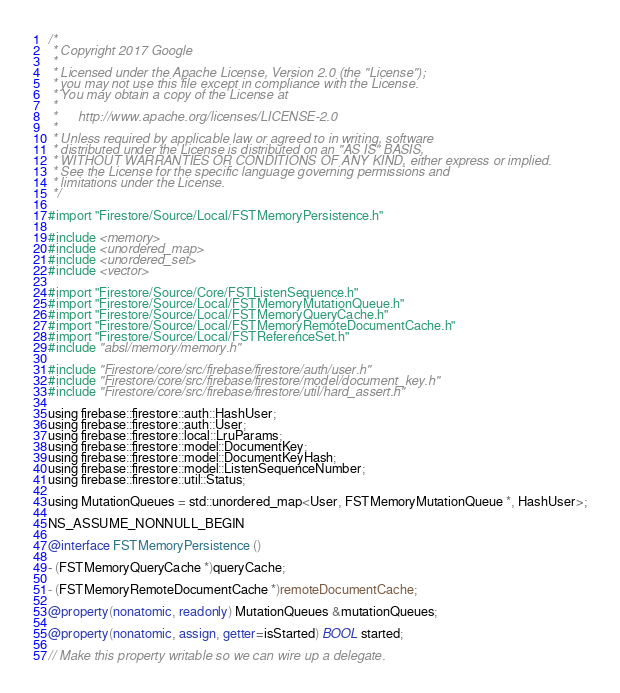Convert code to text. <code><loc_0><loc_0><loc_500><loc_500><_ObjectiveC_>/*
 * Copyright 2017 Google
 *
 * Licensed under the Apache License, Version 2.0 (the "License");
 * you may not use this file except in compliance with the License.
 * You may obtain a copy of the License at
 *
 *      http://www.apache.org/licenses/LICENSE-2.0
 *
 * Unless required by applicable law or agreed to in writing, software
 * distributed under the License is distributed on an "AS IS" BASIS,
 * WITHOUT WARRANTIES OR CONDITIONS OF ANY KIND, either express or implied.
 * See the License for the specific language governing permissions and
 * limitations under the License.
 */

#import "Firestore/Source/Local/FSTMemoryPersistence.h"

#include <memory>
#include <unordered_map>
#include <unordered_set>
#include <vector>

#import "Firestore/Source/Core/FSTListenSequence.h"
#import "Firestore/Source/Local/FSTMemoryMutationQueue.h"
#import "Firestore/Source/Local/FSTMemoryQueryCache.h"
#import "Firestore/Source/Local/FSTMemoryRemoteDocumentCache.h"
#import "Firestore/Source/Local/FSTReferenceSet.h"
#include "absl/memory/memory.h"

#include "Firestore/core/src/firebase/firestore/auth/user.h"
#include "Firestore/core/src/firebase/firestore/model/document_key.h"
#include "Firestore/core/src/firebase/firestore/util/hard_assert.h"

using firebase::firestore::auth::HashUser;
using firebase::firestore::auth::User;
using firebase::firestore::local::LruParams;
using firebase::firestore::model::DocumentKey;
using firebase::firestore::model::DocumentKeyHash;
using firebase::firestore::model::ListenSequenceNumber;
using firebase::firestore::util::Status;

using MutationQueues = std::unordered_map<User, FSTMemoryMutationQueue *, HashUser>;

NS_ASSUME_NONNULL_BEGIN

@interface FSTMemoryPersistence ()

- (FSTMemoryQueryCache *)queryCache;

- (FSTMemoryRemoteDocumentCache *)remoteDocumentCache;

@property(nonatomic, readonly) MutationQueues &mutationQueues;

@property(nonatomic, assign, getter=isStarted) BOOL started;

// Make this property writable so we can wire up a delegate.</code> 